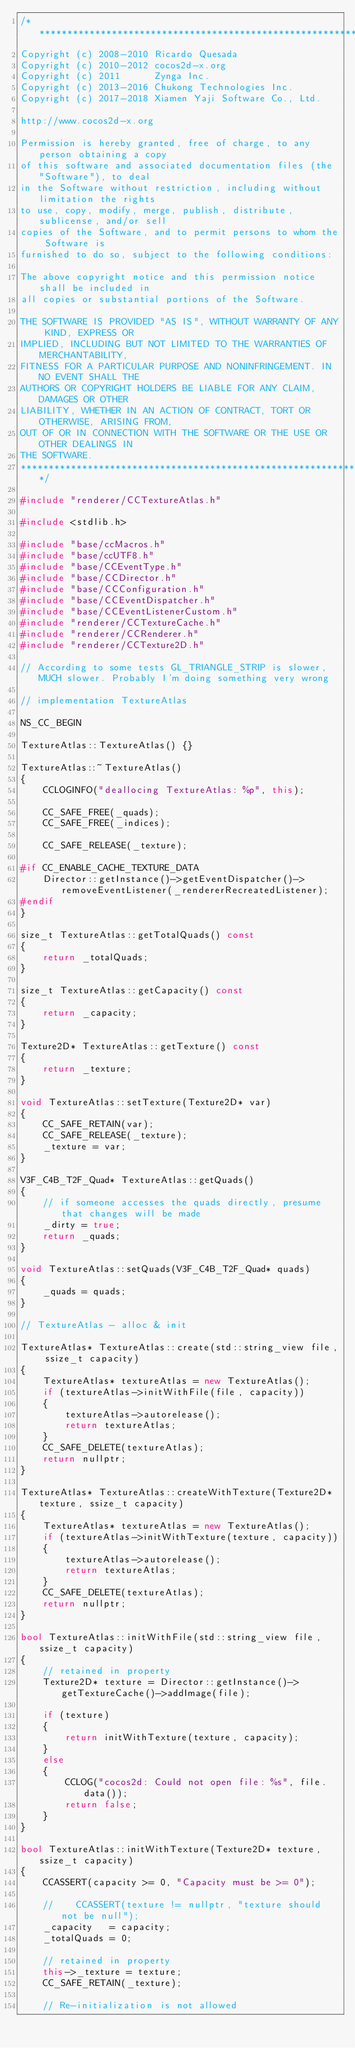<code> <loc_0><loc_0><loc_500><loc_500><_C++_>/****************************************************************************
Copyright (c) 2008-2010 Ricardo Quesada
Copyright (c) 2010-2012 cocos2d-x.org
Copyright (c) 2011      Zynga Inc.
Copyright (c) 2013-2016 Chukong Technologies Inc.
Copyright (c) 2017-2018 Xiamen Yaji Software Co., Ltd.

http://www.cocos2d-x.org

Permission is hereby granted, free of charge, to any person obtaining a copy
of this software and associated documentation files (the "Software"), to deal
in the Software without restriction, including without limitation the rights
to use, copy, modify, merge, publish, distribute, sublicense, and/or sell
copies of the Software, and to permit persons to whom the Software is
furnished to do so, subject to the following conditions:

The above copyright notice and this permission notice shall be included in
all copies or substantial portions of the Software.

THE SOFTWARE IS PROVIDED "AS IS", WITHOUT WARRANTY OF ANY KIND, EXPRESS OR
IMPLIED, INCLUDING BUT NOT LIMITED TO THE WARRANTIES OF MERCHANTABILITY,
FITNESS FOR A PARTICULAR PURPOSE AND NONINFRINGEMENT. IN NO EVENT SHALL THE
AUTHORS OR COPYRIGHT HOLDERS BE LIABLE FOR ANY CLAIM, DAMAGES OR OTHER
LIABILITY, WHETHER IN AN ACTION OF CONTRACT, TORT OR OTHERWISE, ARISING FROM,
OUT OF OR IN CONNECTION WITH THE SOFTWARE OR THE USE OR OTHER DEALINGS IN
THE SOFTWARE.
****************************************************************************/

#include "renderer/CCTextureAtlas.h"

#include <stdlib.h>

#include "base/ccMacros.h"
#include "base/ccUTF8.h"
#include "base/CCEventType.h"
#include "base/CCDirector.h"
#include "base/CCConfiguration.h"
#include "base/CCEventDispatcher.h"
#include "base/CCEventListenerCustom.h"
#include "renderer/CCTextureCache.h"
#include "renderer/CCRenderer.h"
#include "renderer/CCTexture2D.h"

// According to some tests GL_TRIANGLE_STRIP is slower, MUCH slower. Probably I'm doing something very wrong

// implementation TextureAtlas

NS_CC_BEGIN

TextureAtlas::TextureAtlas() {}

TextureAtlas::~TextureAtlas()
{
    CCLOGINFO("deallocing TextureAtlas: %p", this);

    CC_SAFE_FREE(_quads);
    CC_SAFE_FREE(_indices);

    CC_SAFE_RELEASE(_texture);

#if CC_ENABLE_CACHE_TEXTURE_DATA
    Director::getInstance()->getEventDispatcher()->removeEventListener(_rendererRecreatedListener);
#endif
}

size_t TextureAtlas::getTotalQuads() const
{
    return _totalQuads;
}

size_t TextureAtlas::getCapacity() const
{
    return _capacity;
}

Texture2D* TextureAtlas::getTexture() const
{
    return _texture;
}

void TextureAtlas::setTexture(Texture2D* var)
{
    CC_SAFE_RETAIN(var);
    CC_SAFE_RELEASE(_texture);
    _texture = var;
}

V3F_C4B_T2F_Quad* TextureAtlas::getQuads()
{
    // if someone accesses the quads directly, presume that changes will be made
    _dirty = true;
    return _quads;
}

void TextureAtlas::setQuads(V3F_C4B_T2F_Quad* quads)
{
    _quads = quads;
}

// TextureAtlas - alloc & init

TextureAtlas* TextureAtlas::create(std::string_view file, ssize_t capacity)
{
    TextureAtlas* textureAtlas = new TextureAtlas();
    if (textureAtlas->initWithFile(file, capacity))
    {
        textureAtlas->autorelease();
        return textureAtlas;
    }
    CC_SAFE_DELETE(textureAtlas);
    return nullptr;
}

TextureAtlas* TextureAtlas::createWithTexture(Texture2D* texture, ssize_t capacity)
{
    TextureAtlas* textureAtlas = new TextureAtlas();
    if (textureAtlas->initWithTexture(texture, capacity))
    {
        textureAtlas->autorelease();
        return textureAtlas;
    }
    CC_SAFE_DELETE(textureAtlas);
    return nullptr;
}

bool TextureAtlas::initWithFile(std::string_view file, ssize_t capacity)
{
    // retained in property
    Texture2D* texture = Director::getInstance()->getTextureCache()->addImage(file);

    if (texture)
    {
        return initWithTexture(texture, capacity);
    }
    else
    {
        CCLOG("cocos2d: Could not open file: %s", file.data());
        return false;
    }
}

bool TextureAtlas::initWithTexture(Texture2D* texture, ssize_t capacity)
{
    CCASSERT(capacity >= 0, "Capacity must be >= 0");

    //    CCASSERT(texture != nullptr, "texture should not be null");
    _capacity   = capacity;
    _totalQuads = 0;

    // retained in property
    this->_texture = texture;
    CC_SAFE_RETAIN(_texture);

    // Re-initialization is not allowed</code> 